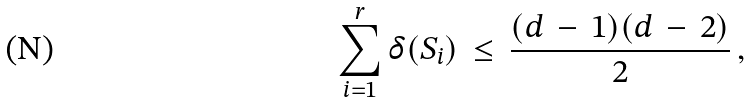Convert formula to latex. <formula><loc_0><loc_0><loc_500><loc_500>\sum _ { i = 1 } ^ { r } \delta ( S _ { i } ) \, \leq \, \frac { ( d \, - \, 1 ) ( d \, - \, 2 ) } { 2 } \, ,</formula> 